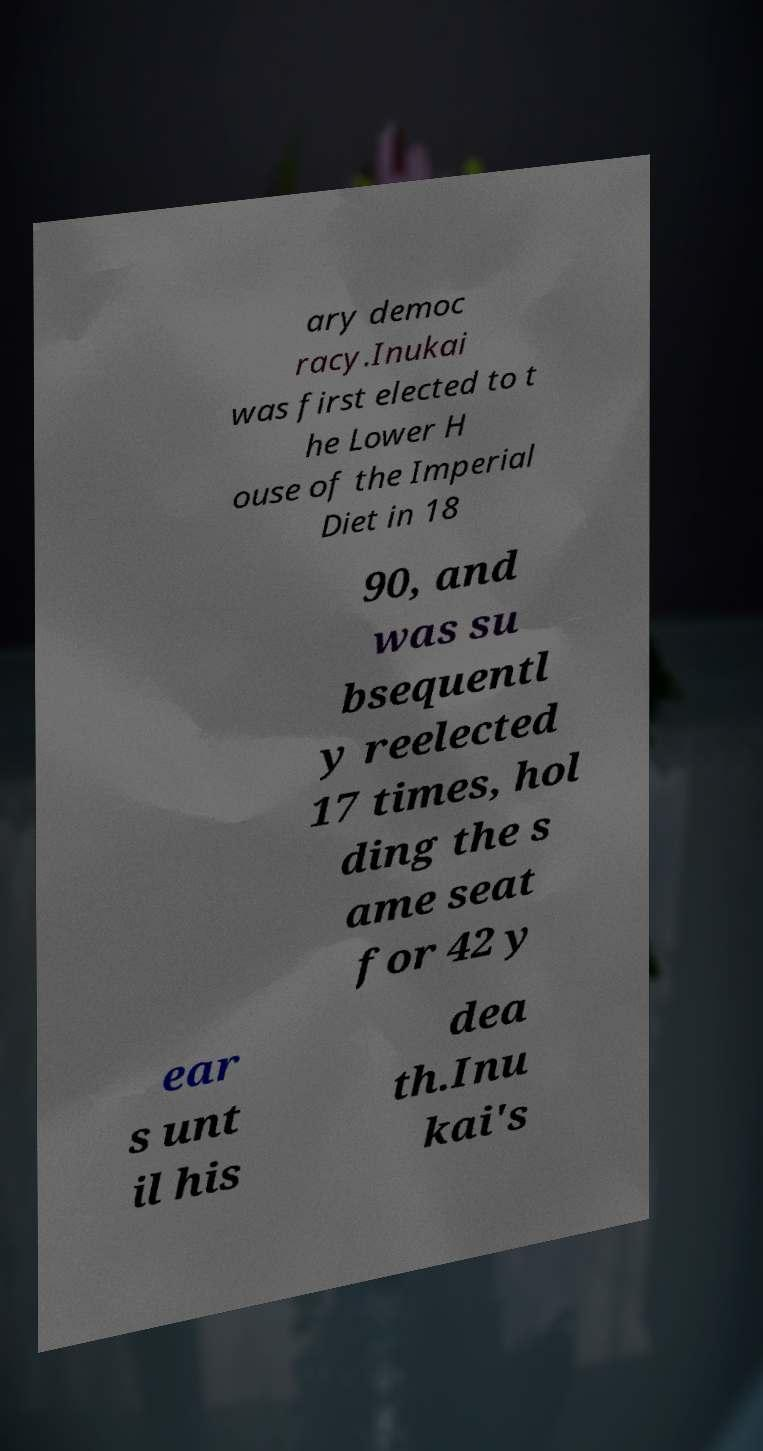Can you read and provide the text displayed in the image?This photo seems to have some interesting text. Can you extract and type it out for me? ary democ racy.Inukai was first elected to t he Lower H ouse of the Imperial Diet in 18 90, and was su bsequentl y reelected 17 times, hol ding the s ame seat for 42 y ear s unt il his dea th.Inu kai's 